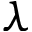<formula> <loc_0><loc_0><loc_500><loc_500>\lambda</formula> 